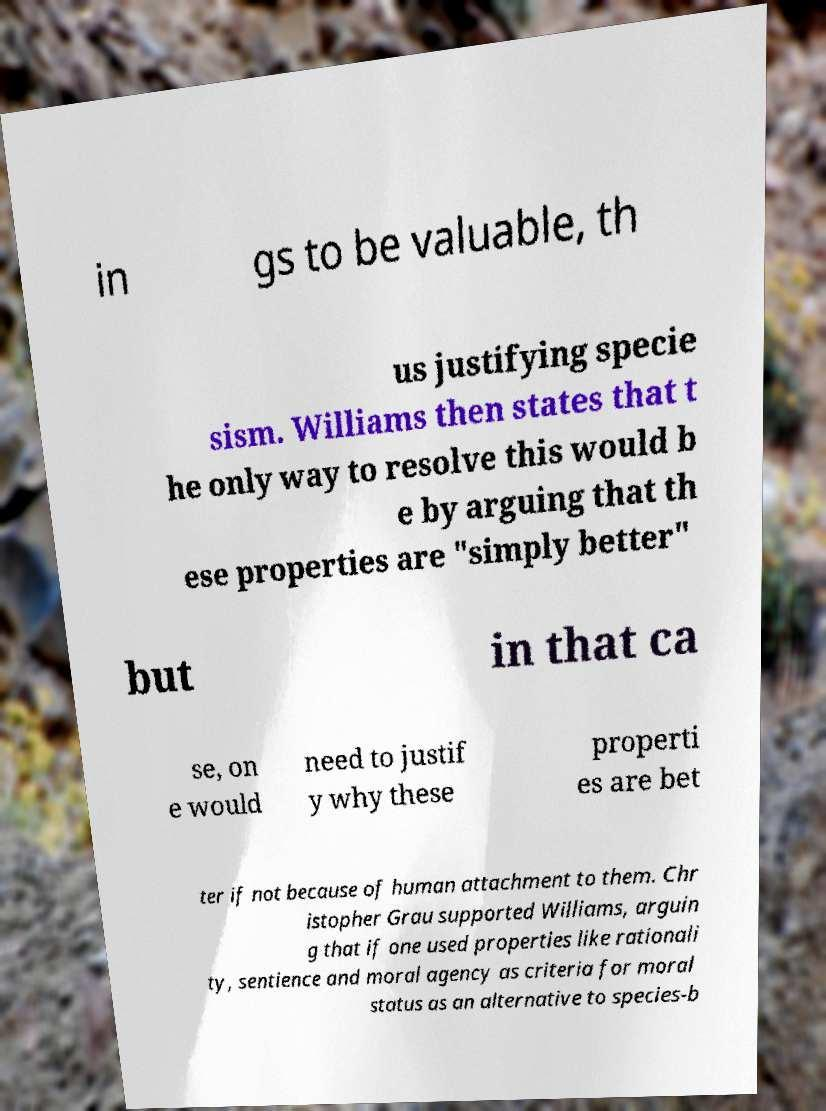Could you extract and type out the text from this image? in gs to be valuable, th us justifying specie sism. Williams then states that t he only way to resolve this would b e by arguing that th ese properties are "simply better" but in that ca se, on e would need to justif y why these properti es are bet ter if not because of human attachment to them. Chr istopher Grau supported Williams, arguin g that if one used properties like rationali ty, sentience and moral agency as criteria for moral status as an alternative to species-b 